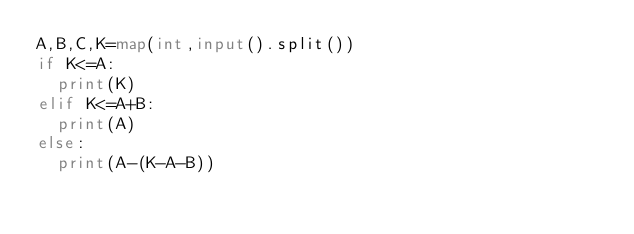Convert code to text. <code><loc_0><loc_0><loc_500><loc_500><_Python_>A,B,C,K=map(int,input().split())
if K<=A:
  print(K)
elif K<=A+B:
  print(A)
else:
  print(A-(K-A-B))</code> 